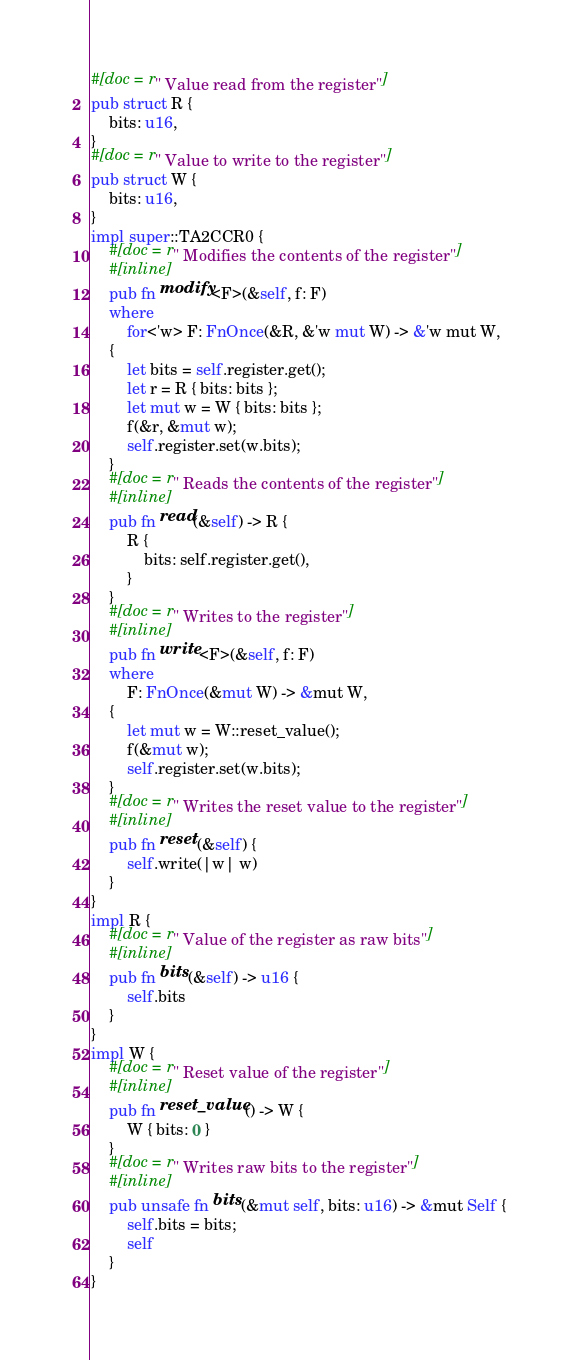Convert code to text. <code><loc_0><loc_0><loc_500><loc_500><_Rust_>#[doc = r" Value read from the register"]
pub struct R {
    bits: u16,
}
#[doc = r" Value to write to the register"]
pub struct W {
    bits: u16,
}
impl super::TA2CCR0 {
    #[doc = r" Modifies the contents of the register"]
    #[inline]
    pub fn modify<F>(&self, f: F)
    where
        for<'w> F: FnOnce(&R, &'w mut W) -> &'w mut W,
    {
        let bits = self.register.get();
        let r = R { bits: bits };
        let mut w = W { bits: bits };
        f(&r, &mut w);
        self.register.set(w.bits);
    }
    #[doc = r" Reads the contents of the register"]
    #[inline]
    pub fn read(&self) -> R {
        R {
            bits: self.register.get(),
        }
    }
    #[doc = r" Writes to the register"]
    #[inline]
    pub fn write<F>(&self, f: F)
    where
        F: FnOnce(&mut W) -> &mut W,
    {
        let mut w = W::reset_value();
        f(&mut w);
        self.register.set(w.bits);
    }
    #[doc = r" Writes the reset value to the register"]
    #[inline]
    pub fn reset(&self) {
        self.write(|w| w)
    }
}
impl R {
    #[doc = r" Value of the register as raw bits"]
    #[inline]
    pub fn bits(&self) -> u16 {
        self.bits
    }
}
impl W {
    #[doc = r" Reset value of the register"]
    #[inline]
    pub fn reset_value() -> W {
        W { bits: 0 }
    }
    #[doc = r" Writes raw bits to the register"]
    #[inline]
    pub unsafe fn bits(&mut self, bits: u16) -> &mut Self {
        self.bits = bits;
        self
    }
}
</code> 